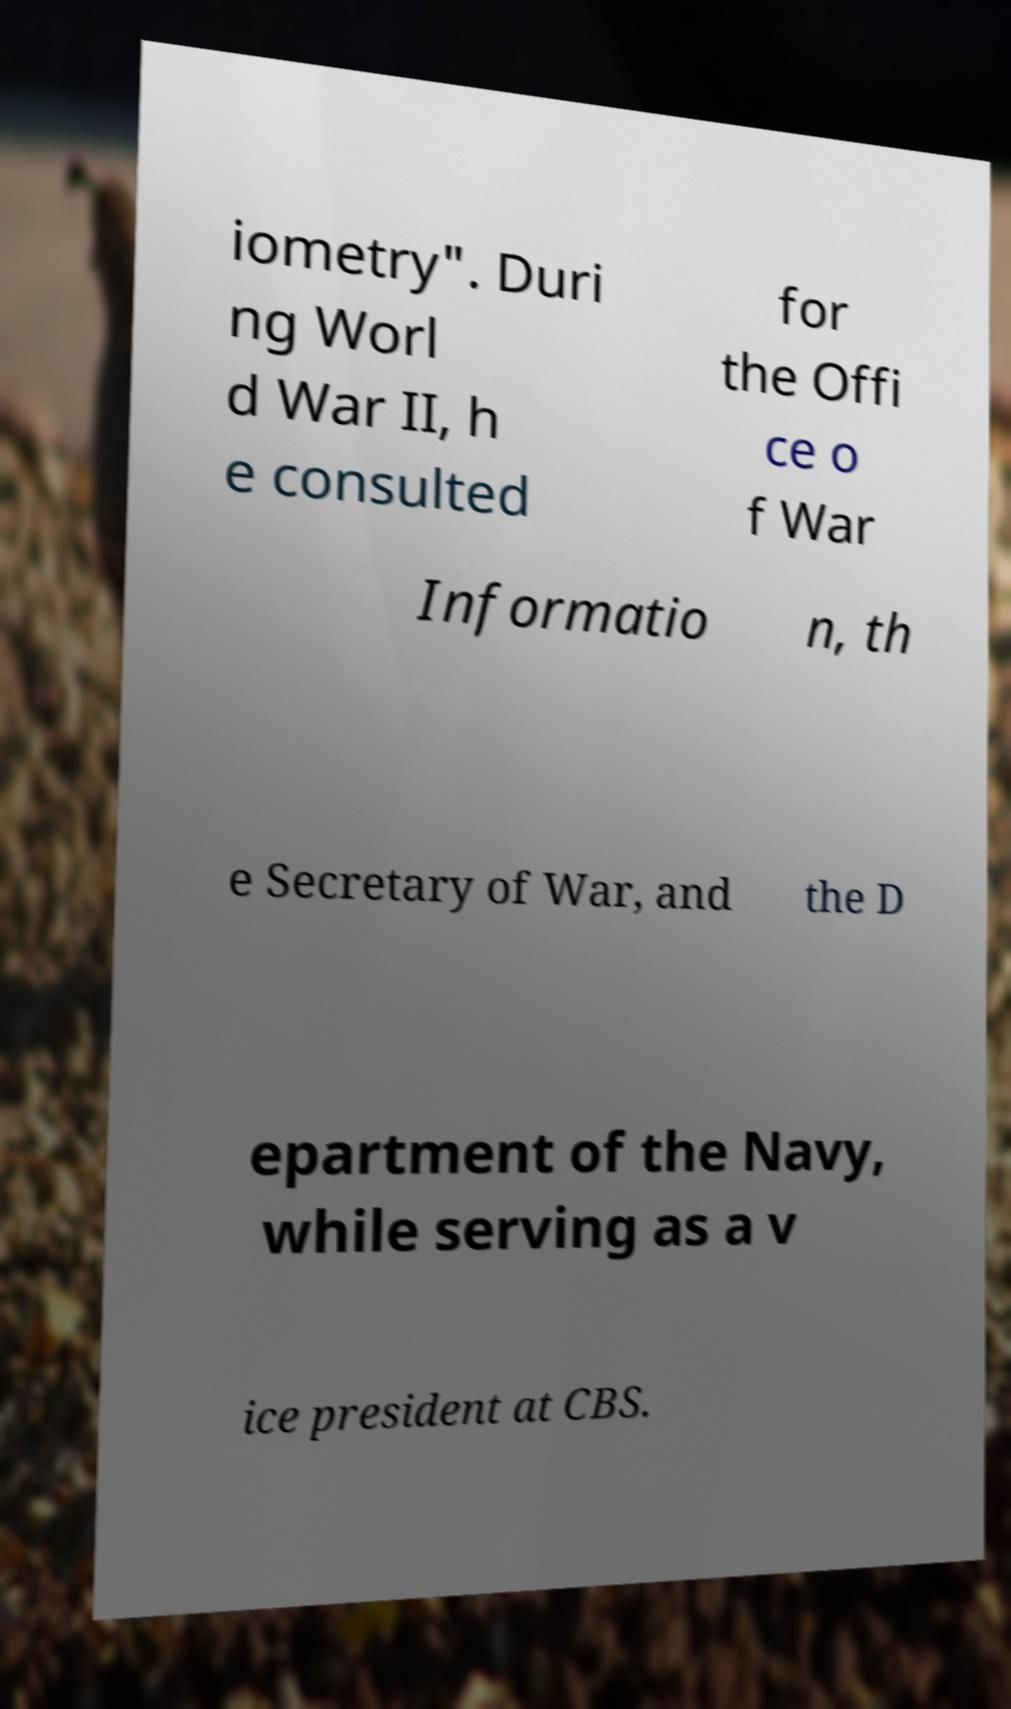Could you extract and type out the text from this image? iometry". Duri ng Worl d War II, h e consulted for the Offi ce o f War Informatio n, th e Secretary of War, and the D epartment of the Navy, while serving as a v ice president at CBS. 